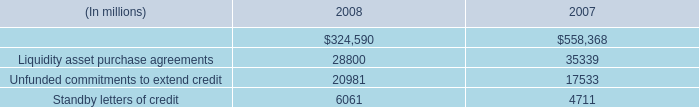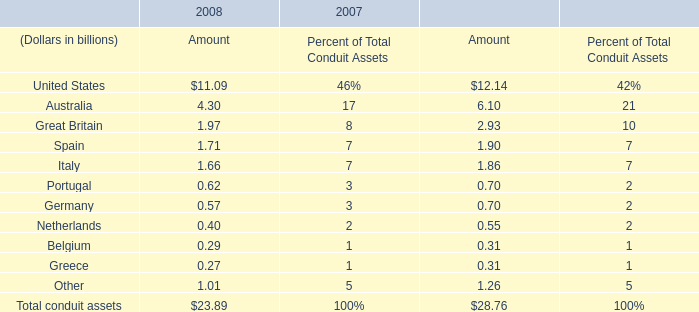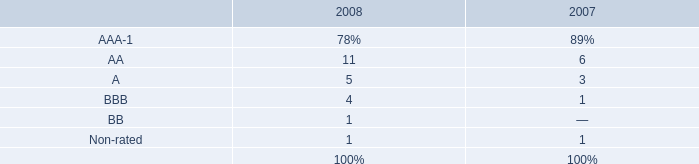what portion of the 2007 collateral was invested in indemnified repurchase agreements in 2007? 
Computations: (106.13 / 572.93)
Answer: 0.18524. 